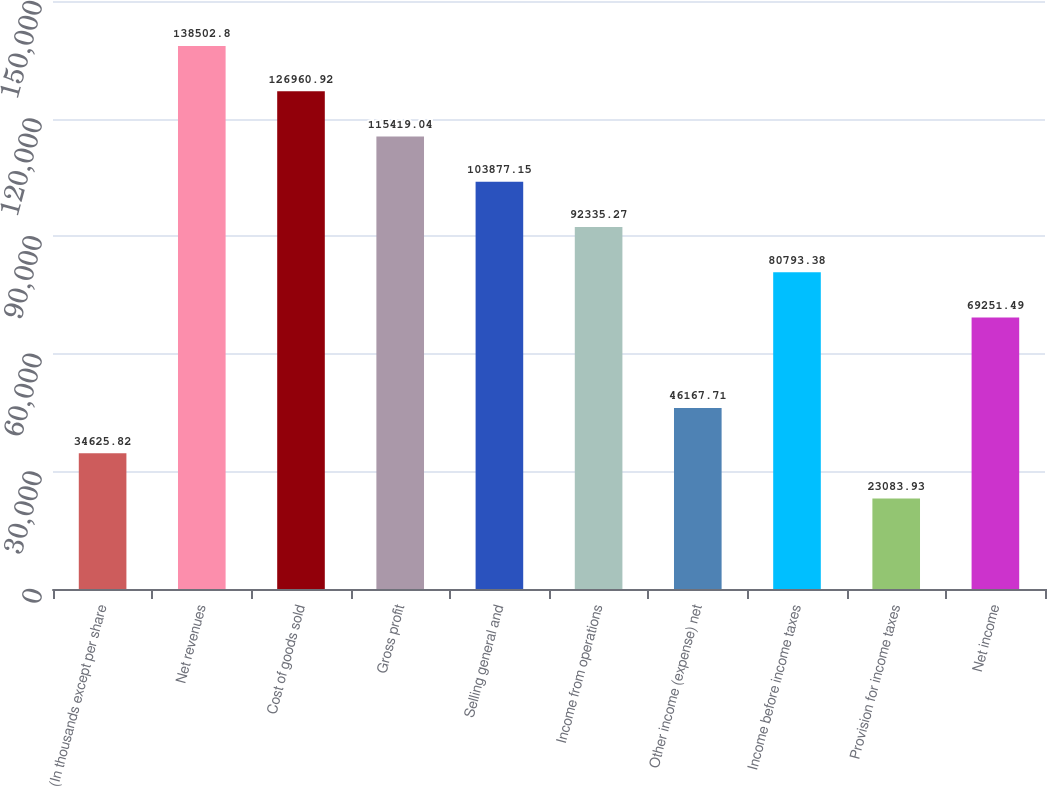Convert chart. <chart><loc_0><loc_0><loc_500><loc_500><bar_chart><fcel>(In thousands except per share<fcel>Net revenues<fcel>Cost of goods sold<fcel>Gross profit<fcel>Selling general and<fcel>Income from operations<fcel>Other income (expense) net<fcel>Income before income taxes<fcel>Provision for income taxes<fcel>Net income<nl><fcel>34625.8<fcel>138503<fcel>126961<fcel>115419<fcel>103877<fcel>92335.3<fcel>46167.7<fcel>80793.4<fcel>23083.9<fcel>69251.5<nl></chart> 